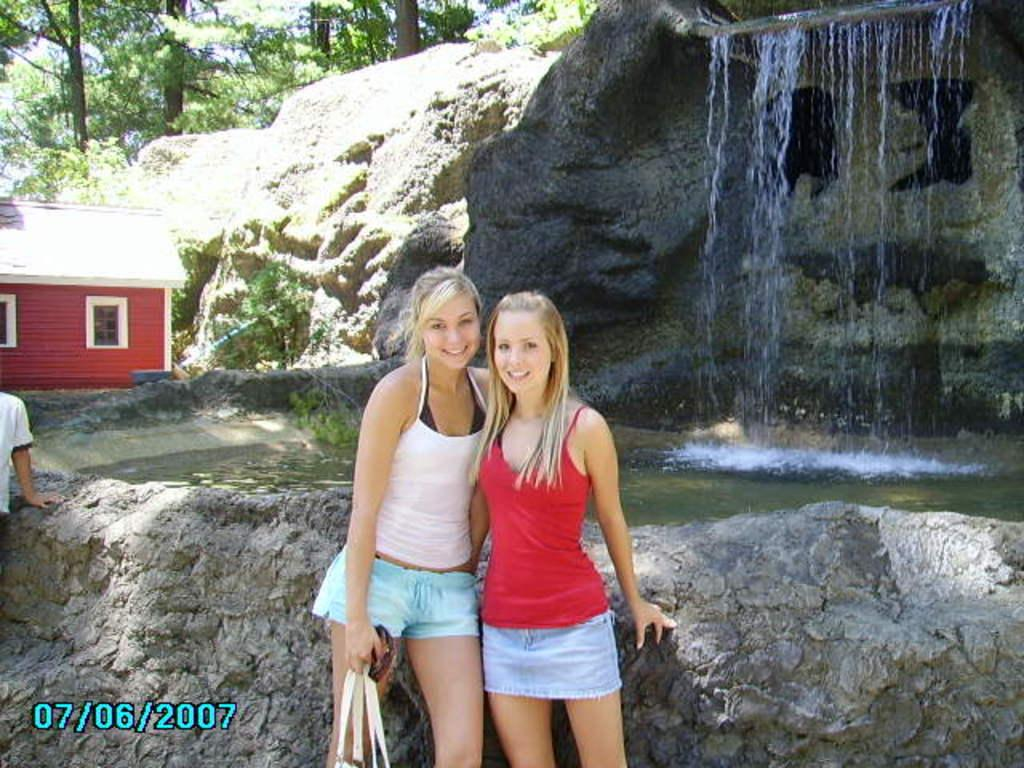<image>
Offer a succinct explanation of the picture presented. a person with the date of 07/06/2007 next to them 